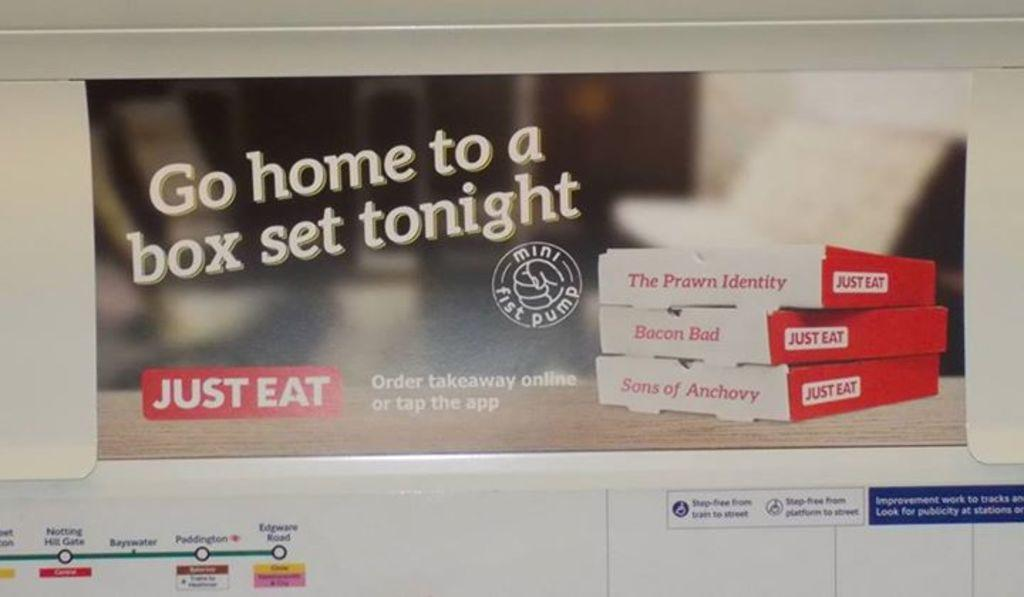<image>
Create a compact narrative representing the image presented. An add for food has the tag line, just eat. 